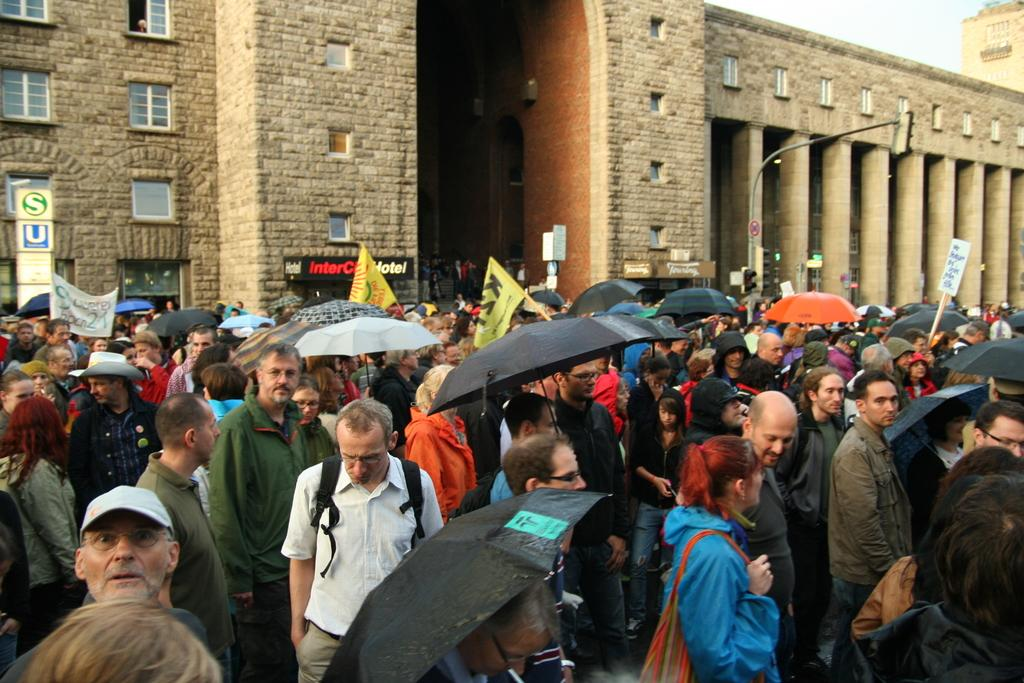How many people are in the image? There is a group of people in the image, but the exact number is not specified. What are the people doing in the image? The people are standing, holding umbrellas, placards, and flags. What can be seen in the background of the image? The sky is visible in the background of the image. What architectural features are present in the image? There are boards, pillars, and a building in the image. What direction is the pen pointing in the image? There is no pen present in the image. Which person's knee is visible in the image? The provided facts do not mention any visible knees, so it cannot be determined from the image. 